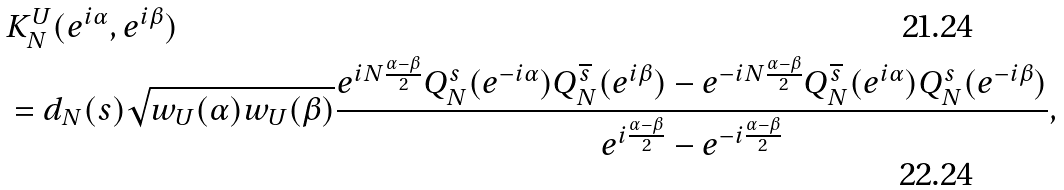Convert formula to latex. <formula><loc_0><loc_0><loc_500><loc_500>& K _ { N } ^ { U } ( e ^ { i \alpha } , e ^ { i \beta } ) \\ & = d _ { N } ( s ) \sqrt { w _ { U } ( \alpha ) w _ { U } ( \beta ) } \frac { e ^ { i N \frac { \alpha - \beta } { 2 } } Q _ { N } ^ { s } ( e ^ { - i \alpha } ) Q _ { N } ^ { \overline { s } } ( e ^ { i \beta } ) - e ^ { - i N \frac { \alpha - \beta } { 2 } } Q _ { N } ^ { \overline { s } } ( e ^ { i \alpha } ) Q _ { N } ^ { s } ( e ^ { - i \beta } ) } { e ^ { i \frac { \alpha - \beta } { 2 } } - e ^ { - i \frac { \alpha - \beta } { 2 } } } ,</formula> 